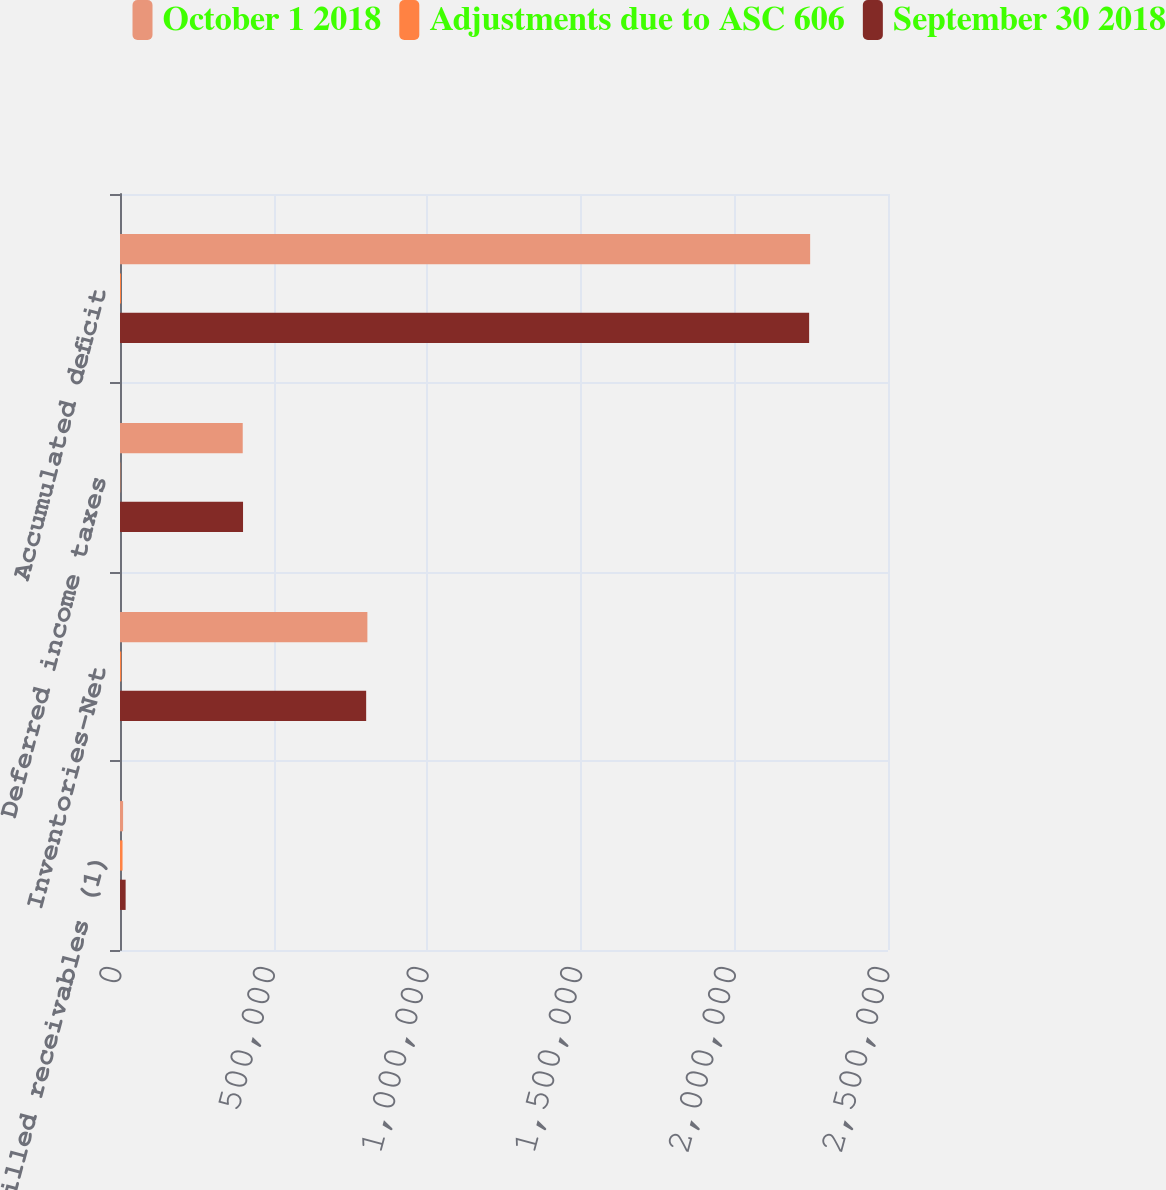<chart> <loc_0><loc_0><loc_500><loc_500><stacked_bar_chart><ecel><fcel>Unbilled receivables (1)<fcel>Inventories-Net<fcel>Deferred income taxes<fcel>Accumulated deficit<nl><fcel>October 1 2018<fcel>10056<fcel>805292<fcel>399496<fcel>2.24658e+06<nl><fcel>Adjustments due to ASC 606<fcel>8272<fcel>3977<fcel>1011<fcel>3284<nl><fcel>September 30 2018<fcel>18328<fcel>801315<fcel>400507<fcel>2.24329e+06<nl></chart> 